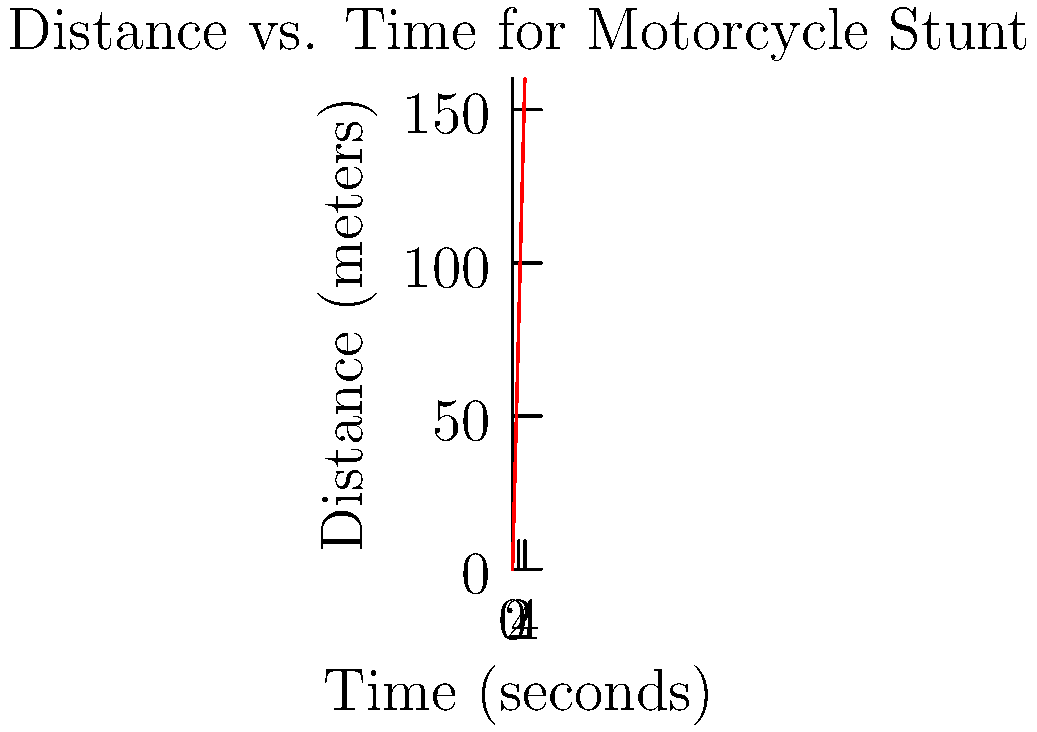You're watching a thrilling motorcycle stunt from your porch. The rider accelerates in a straight line, and you've recorded their progress in the chart above. What is the average speed of the motorcycle during this 4-second stunt? To find the average speed, we need to follow these steps:

1. Identify the total distance traveled:
   From the graph, we can see that at 4 seconds, the distance is 160 meters.

2. Identify the total time taken:
   The graph shows the stunt lasting for 4 seconds.

3. Use the formula for average speed:
   Average Speed = Total Distance / Total Time

4. Plug in the values:
   Average Speed = 160 meters / 4 seconds

5. Calculate:
   Average Speed = 40 meters per second

Therefore, the average speed of the motorcycle during this 4-second stunt is 40 meters per second.
Answer: 40 m/s 